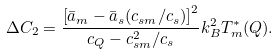Convert formula to latex. <formula><loc_0><loc_0><loc_500><loc_500>\Delta C _ { 2 } = \frac { \left [ \bar { a } _ { m } - \bar { a } _ { s } ( c _ { s m } / c _ { s } ) \right ] ^ { 2 } } { c _ { Q } - c _ { s m } ^ { 2 } / c _ { s } } k _ { B } ^ { 2 } T _ { m } ^ { * } ( { Q } ) .</formula> 